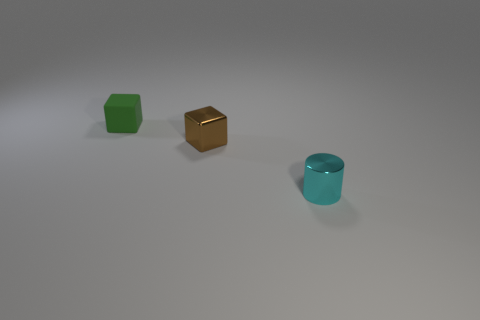Is the number of blocks that are left of the tiny cyan shiny object greater than the number of green rubber blocks that are to the left of the green thing?
Give a very brief answer. Yes. Are there any green rubber blocks left of the rubber block?
Keep it short and to the point. No. What material is the tiny thing that is to the right of the rubber block and behind the small cyan metal cylinder?
Your answer should be compact. Metal. There is another small thing that is the same shape as the small brown thing; what is its color?
Offer a very short reply. Green. Is there a tiny matte block on the right side of the block that is in front of the tiny rubber block?
Offer a very short reply. No. The green cube has what size?
Your answer should be very brief. Small. What is the shape of the small thing that is in front of the matte thing and on the left side of the tiny cyan cylinder?
Ensure brevity in your answer.  Cube. How many green things are either tiny matte things or small things?
Provide a succinct answer. 1. Is the size of the metallic thing left of the cyan metal cylinder the same as the rubber object that is behind the metal cube?
Provide a succinct answer. Yes. What number of things are either small cyan shiny cylinders or tiny blue shiny things?
Make the answer very short. 1. 